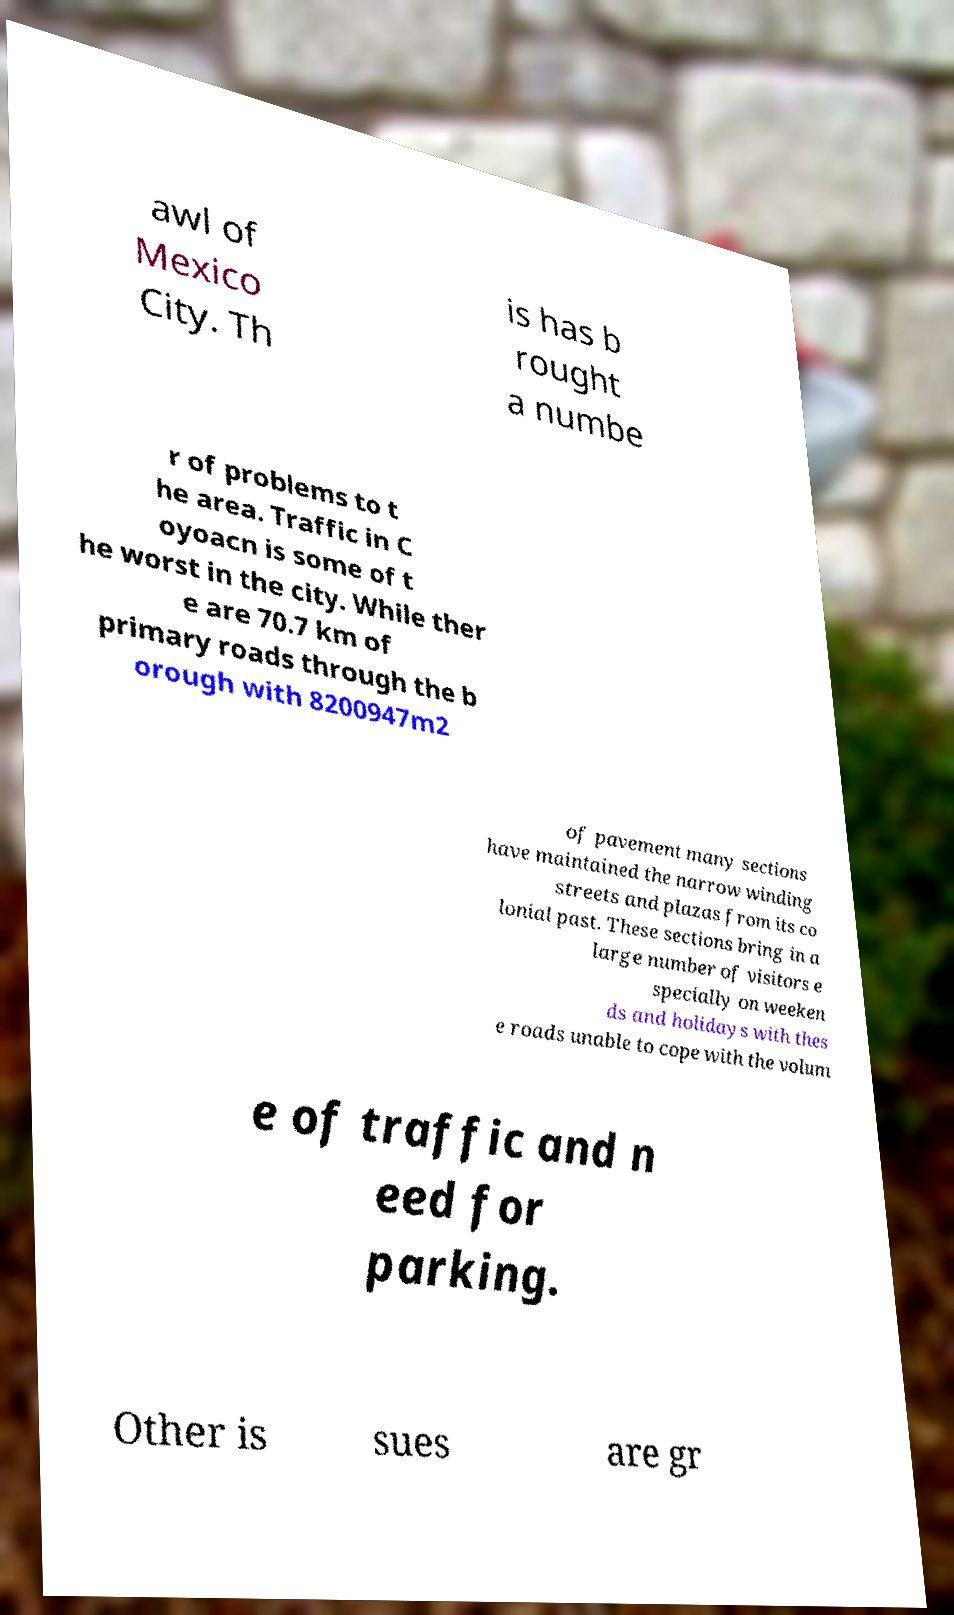Could you assist in decoding the text presented in this image and type it out clearly? awl of Mexico City. Th is has b rought a numbe r of problems to t he area. Traffic in C oyoacn is some of t he worst in the city. While ther e are 70.7 km of primary roads through the b orough with 8200947m2 of pavement many sections have maintained the narrow winding streets and plazas from its co lonial past. These sections bring in a large number of visitors e specially on weeken ds and holidays with thes e roads unable to cope with the volum e of traffic and n eed for parking. Other is sues are gr 